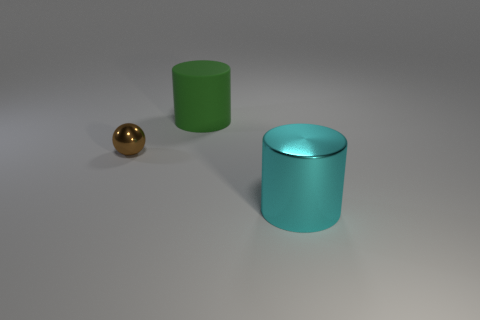Add 1 large cyan metallic things. How many objects exist? 4 Subtract all cylinders. How many objects are left? 1 Add 1 brown balls. How many brown balls are left? 2 Add 2 big brown spheres. How many big brown spheres exist? 2 Subtract 0 cyan blocks. How many objects are left? 3 Subtract all tiny yellow metallic things. Subtract all tiny metallic things. How many objects are left? 2 